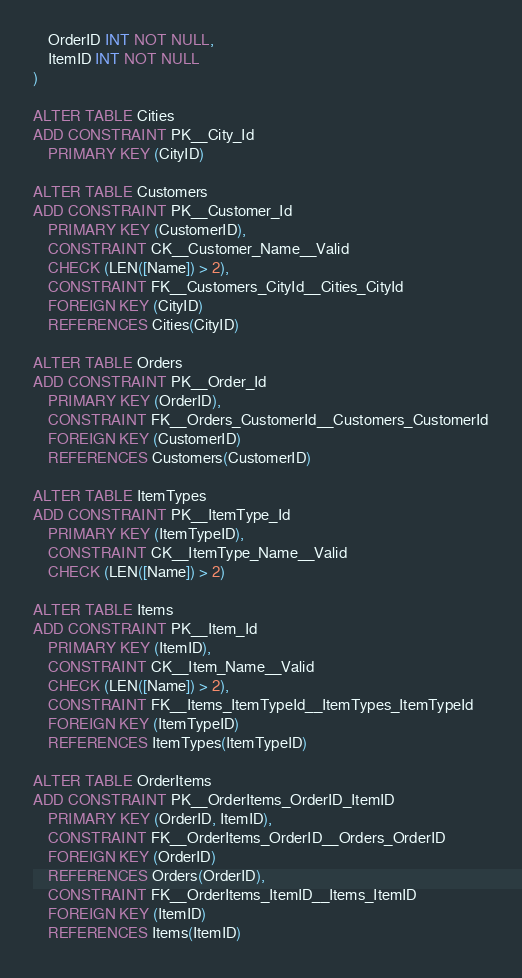<code> <loc_0><loc_0><loc_500><loc_500><_SQL_>	OrderID INT NOT NULL,
	ItemID INT NOT NULL
)

ALTER TABLE Cities
ADD CONSTRAINT PK__City_Id
	PRIMARY KEY (CityID)

ALTER TABLE Customers
ADD CONSTRAINT PK__Customer_Id
	PRIMARY KEY (CustomerID),
	CONSTRAINT CK__Customer_Name__Valid
	CHECK (LEN([Name]) > 2),
	CONSTRAINT FK__Customers_CityId__Cities_CityId
	FOREIGN KEY (CityID)
	REFERENCES Cities(CityID)

ALTER TABLE Orders
ADD CONSTRAINT PK__Order_Id
	PRIMARY KEY (OrderID),
	CONSTRAINT FK__Orders_CustomerId__Customers_CustomerId
	FOREIGN KEY (CustomerID)
	REFERENCES Customers(CustomerID)

ALTER TABLE ItemTypes
ADD CONSTRAINT PK__ItemType_Id
	PRIMARY KEY (ItemTypeID),
	CONSTRAINT CK__ItemType_Name__Valid
	CHECK (LEN([Name]) > 2)

ALTER TABLE Items
ADD CONSTRAINT PK__Item_Id
	PRIMARY KEY (ItemID),
	CONSTRAINT CK__Item_Name__Valid
	CHECK (LEN([Name]) > 2),
	CONSTRAINT FK__Items_ItemTypeId__ItemTypes_ItemTypeId
	FOREIGN KEY (ItemTypeID)
	REFERENCES ItemTypes(ItemTypeID)

ALTER TABLE OrderItems
ADD CONSTRAINT PK__OrderItems_OrderID_ItemID
	PRIMARY KEY (OrderID, ItemID),
	CONSTRAINT FK__OrderItems_OrderID__Orders_OrderID
	FOREIGN KEY (OrderID)
	REFERENCES Orders(OrderID),
	CONSTRAINT FK__OrderItems_ItemID__Items_ItemID
	FOREIGN KEY (ItemID)
	REFERENCES Items(ItemID)
</code> 